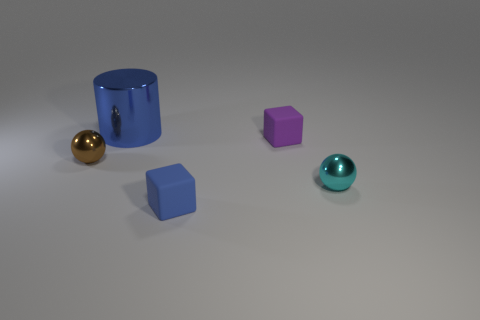Add 5 objects. How many objects exist? 10 Subtract all balls. How many objects are left? 3 Subtract all green cubes. Subtract all small brown things. How many objects are left? 4 Add 4 large cylinders. How many large cylinders are left? 5 Add 1 big brown shiny cylinders. How many big brown shiny cylinders exist? 1 Subtract 1 brown balls. How many objects are left? 4 Subtract all brown blocks. Subtract all gray cylinders. How many blocks are left? 2 